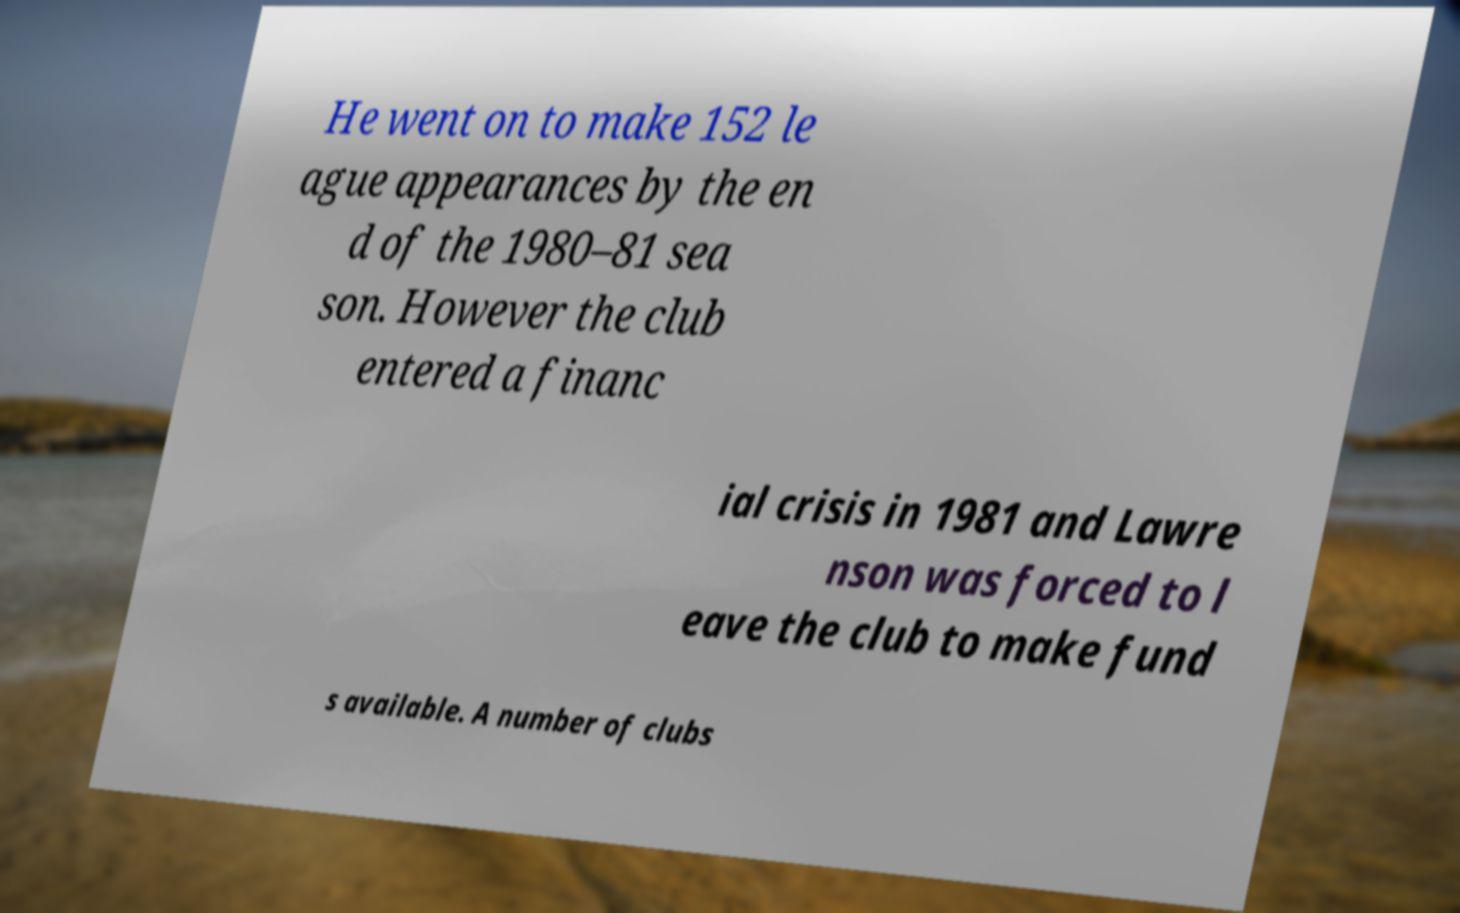I need the written content from this picture converted into text. Can you do that? He went on to make 152 le ague appearances by the en d of the 1980–81 sea son. However the club entered a financ ial crisis in 1981 and Lawre nson was forced to l eave the club to make fund s available. A number of clubs 